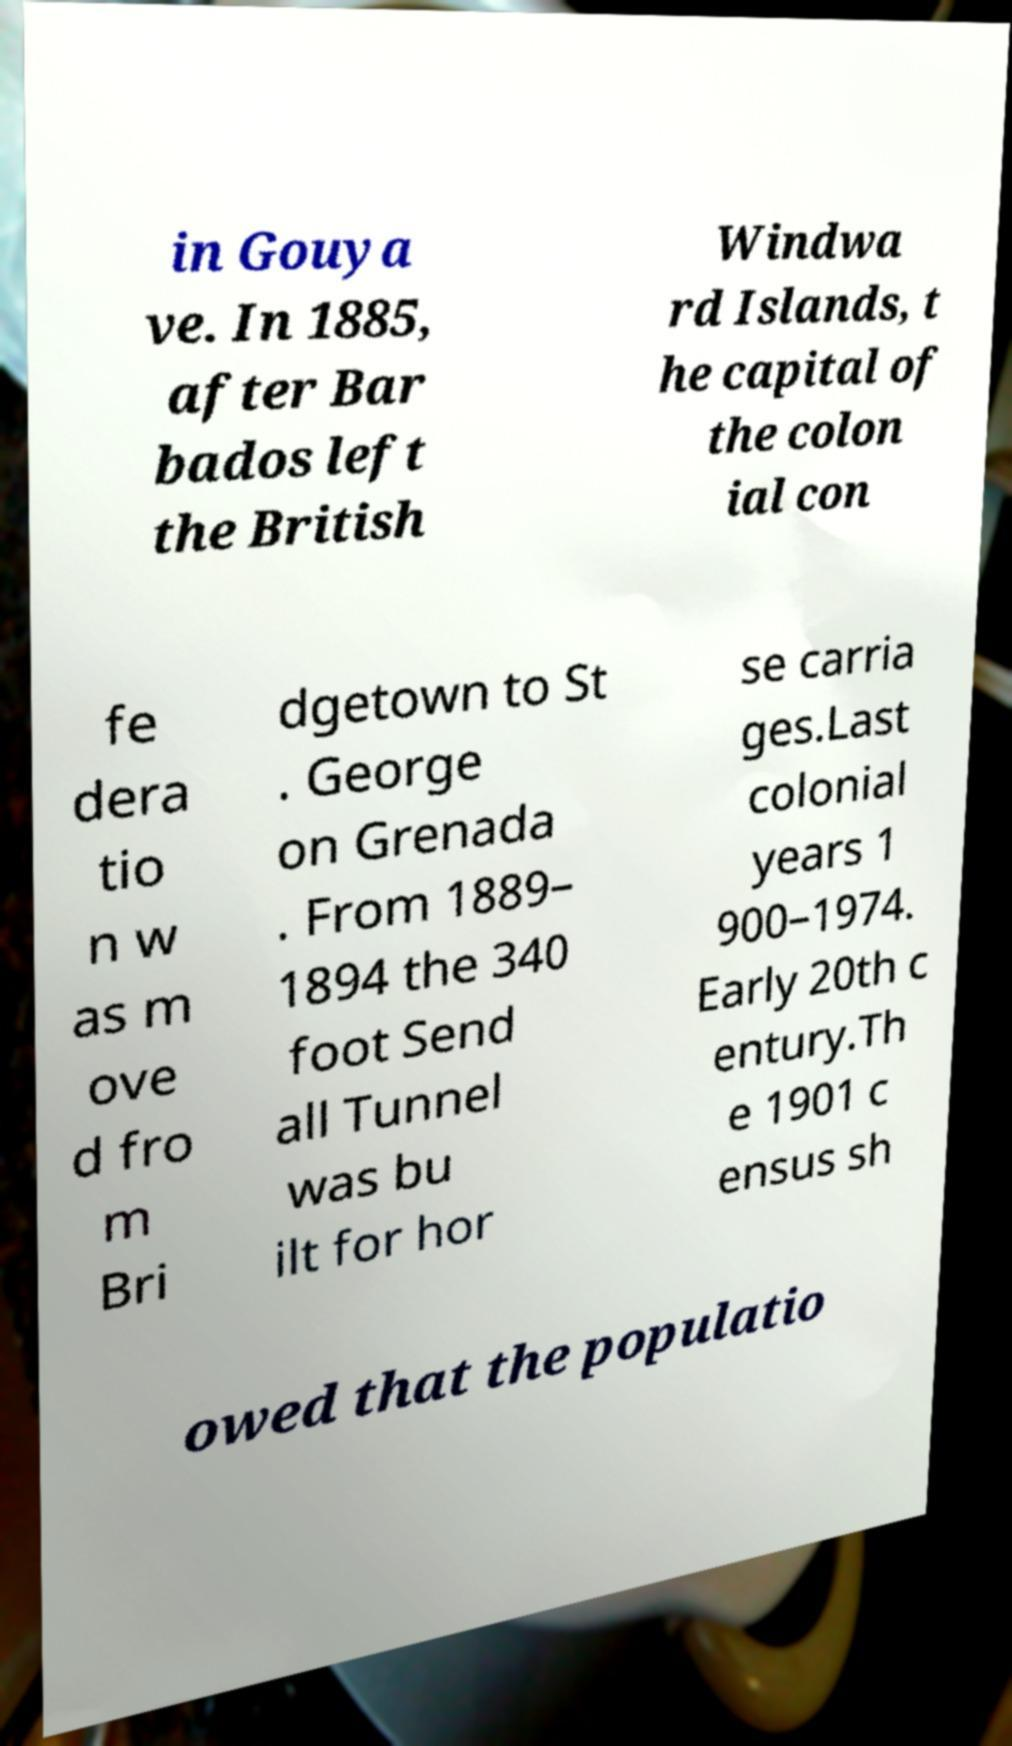I need the written content from this picture converted into text. Can you do that? in Gouya ve. In 1885, after Bar bados left the British Windwa rd Islands, t he capital of the colon ial con fe dera tio n w as m ove d fro m Bri dgetown to St . George on Grenada . From 1889– 1894 the 340 foot Send all Tunnel was bu ilt for hor se carria ges.Last colonial years 1 900–1974. Early 20th c entury.Th e 1901 c ensus sh owed that the populatio 